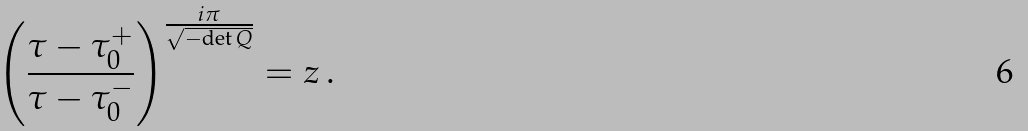Convert formula to latex. <formula><loc_0><loc_0><loc_500><loc_500>\left ( \frac { \tau - \tau _ { 0 } ^ { + } } { \tau - \tau _ { 0 } ^ { - } } \right ) ^ { \frac { i \pi } { \sqrt { - \text {det} \, Q } } } = z \, .</formula> 